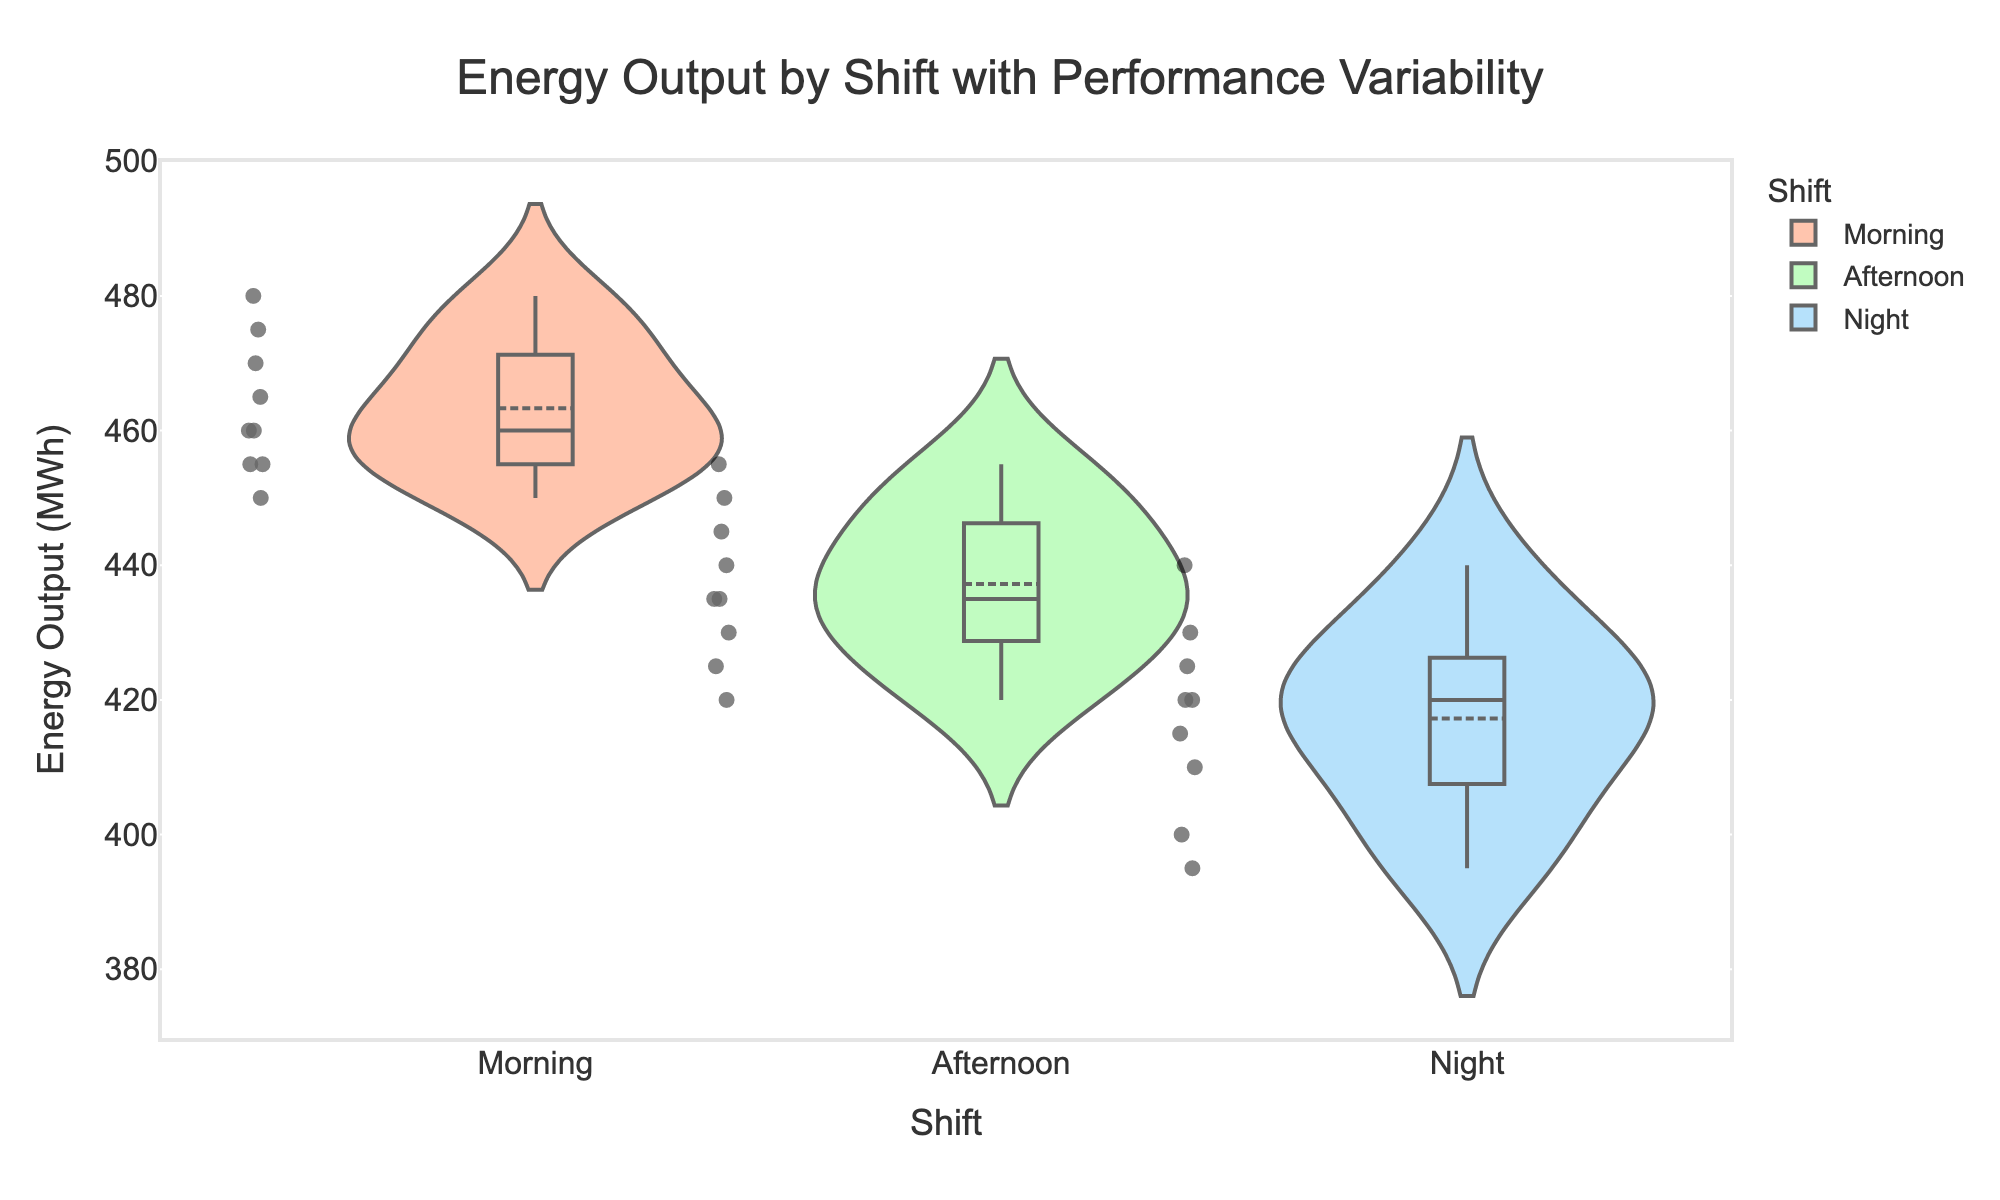What is the title of the chart? The title is usually displayed at the top of the chart and is used to convey the theme or main point of the visualization.
Answer: Energy Output by Shift with Performance Variability Which shift has the highest median energy output? Look at the central line in the box plot for each shift; the median for Morning is the highest.
Answer: Morning Which shift has the lowest mean energy output? The mean is shown by a dashed line in each violin plot; the Night shift has the lowest mean.
Answer: Night Which shift shows the most variability in energy output? Assess the width of each violin plot; the Night shift has the widest range, indicating the most variability.
Answer: Night How many data points are there for the Morning shift? Count the individual points shown within the Morning violin plot. There are 9 points.
Answer: 9 What is the range of energy output values for the Afternoon shift? Look at the highest and lowest points within the Afternoon violin plot; the range is 420 to 455 MWh.
Answer: 35 MWh What is the interquartile range (IQR) for the Morning shift? The IQR is the range between the 25th and 75th percentiles in the box plot within the violin; for Morning, it's from approximately 460 to 470 MWh.
Answer: 10 MWh Compare the median energy output of the Morning and Afternoon shifts. Which is higher? The line in the middle of the Morning box plot is higher than the line in the Afternoon box plot.
Answer: Morning Identify the shift with the least number of data points. By counting the points within each violin plot, all shifts have the same number of data points: 9.
Answer: All shifts have equal data points Are there any outliers in the Night shift data? Outliers are individual points far from the main data cluster; there are no distinct outliers visible in the Night shift plot.
Answer: No 